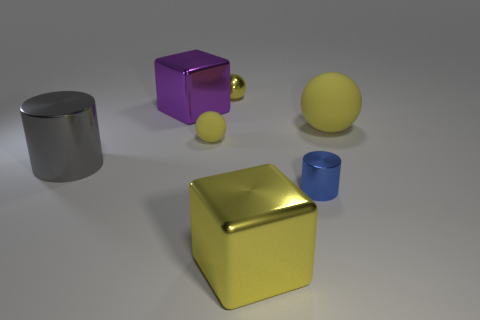Do the tiny object to the right of the large yellow metallic thing and the gray metallic object have the same shape?
Your answer should be very brief. Yes. What number of purple things are metal blocks or tiny spheres?
Your answer should be compact. 1. Is the number of large cubes greater than the number of large cyan blocks?
Your answer should be very brief. Yes. What color is the rubber sphere that is the same size as the gray metallic object?
Your response must be concise. Yellow. What number of balls are large purple metal things or tiny red metal objects?
Provide a short and direct response. 0. There is a purple metal thing; is its shape the same as the big metallic object that is to the right of the large purple shiny object?
Give a very brief answer. Yes. How many cylinders are the same size as the yellow metal sphere?
Your answer should be very brief. 1. Does the yellow matte object that is to the right of the tiny yellow matte object have the same shape as the big thing that is in front of the large gray thing?
Offer a terse response. No. There is a large shiny thing that is the same color as the small rubber thing; what is its shape?
Offer a terse response. Cube. What is the color of the big shiny cube that is in front of the small yellow ball in front of the large matte ball?
Provide a short and direct response. Yellow. 